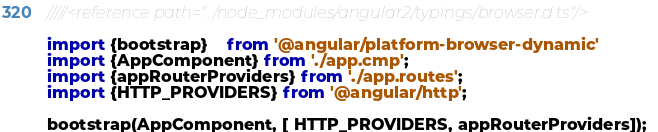Convert code to text. <code><loc_0><loc_0><loc_500><loc_500><_TypeScript_>/////<reference path="../node_modules/angular2/typings/browser.d.ts"/>

import {bootstrap}    from '@angular/platform-browser-dynamic'
import {AppComponent} from './app.cmp';
import {appRouterProviders} from './app.routes';
import {HTTP_PROVIDERS} from '@angular/http';

bootstrap(AppComponent, [ HTTP_PROVIDERS, appRouterProviders]);
</code> 